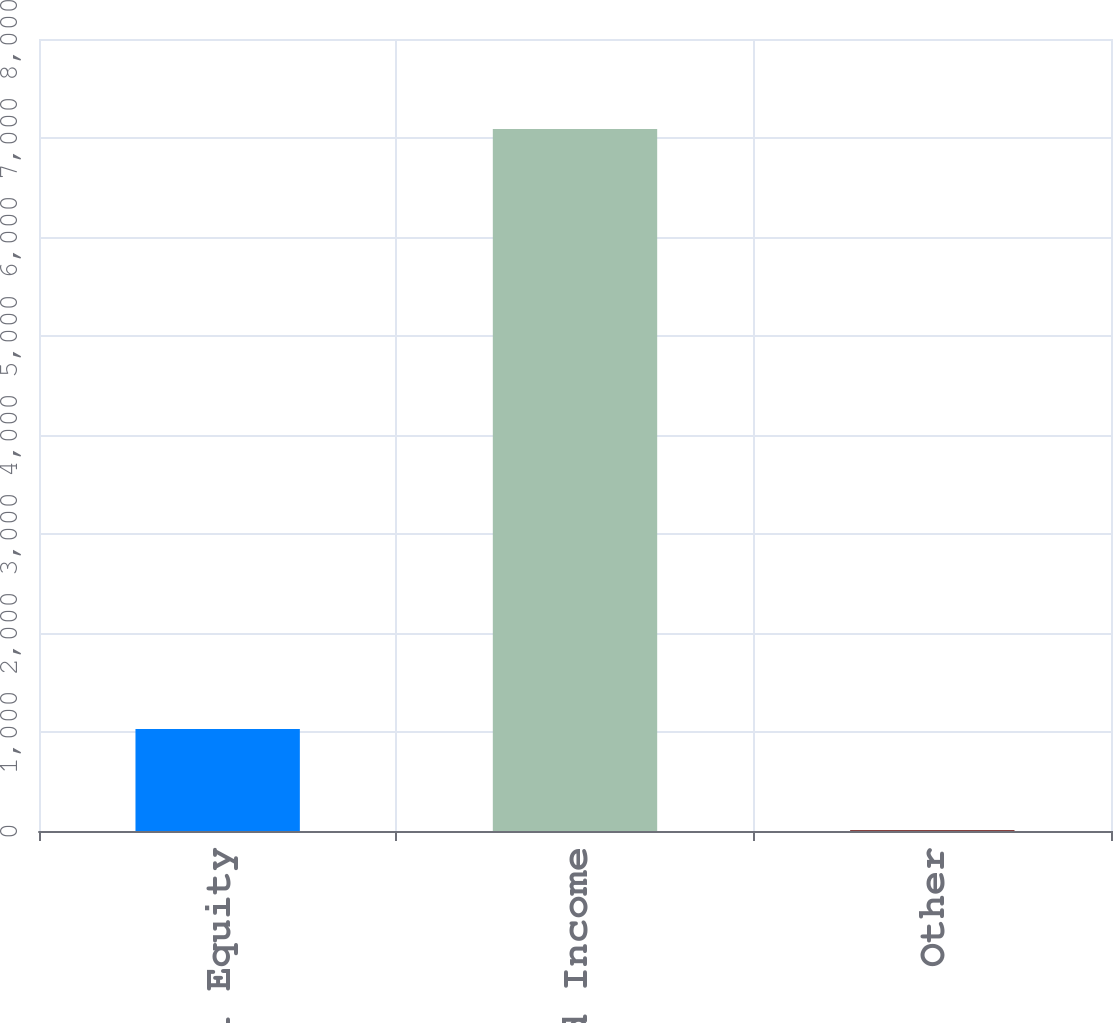<chart> <loc_0><loc_0><loc_500><loc_500><bar_chart><fcel>Total Equity<fcel>Total Fixed Income<fcel>Other<nl><fcel>1030<fcel>7090<fcel>10<nl></chart> 